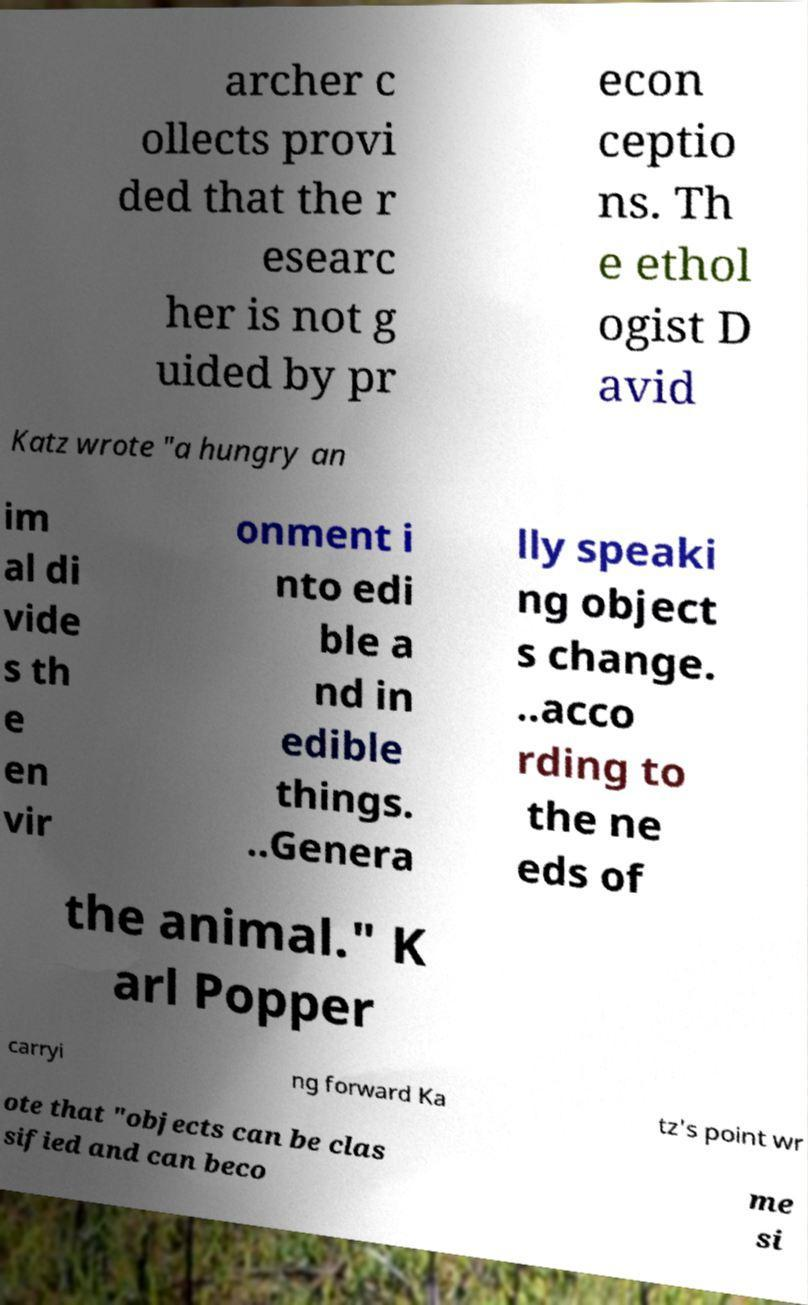Can you read and provide the text displayed in the image?This photo seems to have some interesting text. Can you extract and type it out for me? archer c ollects provi ded that the r esearc her is not g uided by pr econ ceptio ns. Th e ethol ogist D avid Katz wrote "a hungry an im al di vide s th e en vir onment i nto edi ble a nd in edible things. ..Genera lly speaki ng object s change. ..acco rding to the ne eds of the animal." K arl Popper carryi ng forward Ka tz's point wr ote that "objects can be clas sified and can beco me si 